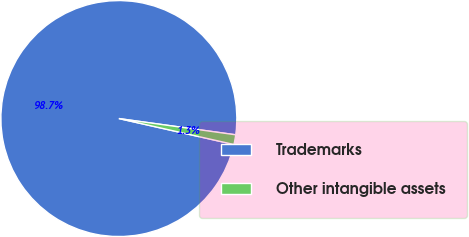Convert chart. <chart><loc_0><loc_0><loc_500><loc_500><pie_chart><fcel>Trademarks<fcel>Other intangible assets<nl><fcel>98.67%<fcel>1.33%<nl></chart> 